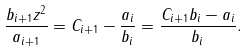<formula> <loc_0><loc_0><loc_500><loc_500>\frac { b _ { i + 1 } z ^ { 2 } } { a _ { i + 1 } } = C _ { i + 1 } - \frac { a _ { i } } { b _ { i } } = \frac { C _ { i + 1 } b _ { i } - a _ { i } } { b _ { i } } .</formula> 